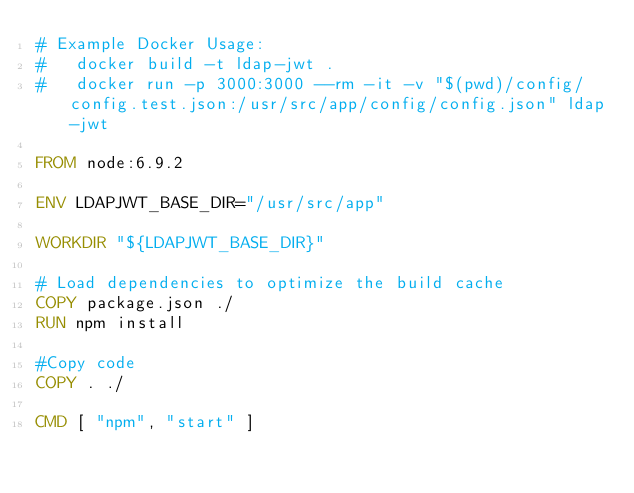Convert code to text. <code><loc_0><loc_0><loc_500><loc_500><_Dockerfile_># Example Docker Usage:
#   docker build -t ldap-jwt .
#   docker run -p 3000:3000 --rm -it -v "$(pwd)/config/config.test.json:/usr/src/app/config/config.json" ldap-jwt

FROM node:6.9.2

ENV LDAPJWT_BASE_DIR="/usr/src/app"

WORKDIR "${LDAPJWT_BASE_DIR}"

# Load dependencies to optimize the build cache
COPY package.json ./
RUN npm install

#Copy code
COPY . ./

CMD [ "npm", "start" ]
</code> 